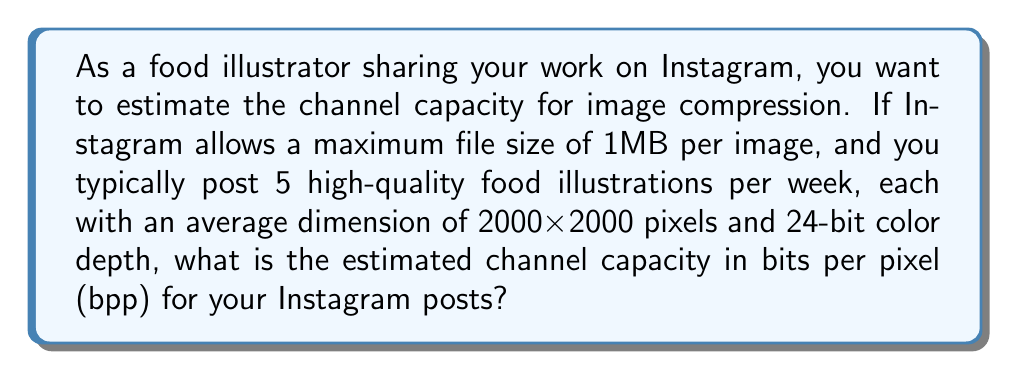Give your solution to this math problem. To solve this problem, we need to follow these steps:

1. Calculate the total number of pixels in each image:
   $$ \text{Total pixels} = 2000 \times 2000 = 4,000,000 \text{ pixels} $$

2. Convert the file size limit from MB to bits:
   $$ 1 \text{MB} = 1,000,000 \text{ bytes} = 8,000,000 \text{ bits} $$

3. Calculate the channel capacity in bits per pixel (bpp):
   $$ \text{Channel capacity} = \frac{\text{File size in bits}}{\text{Total pixels}} $$
   $$ \text{Channel capacity} = \frac{8,000,000 \text{ bits}}{4,000,000 \text{ pixels}} = 2 \text{ bpp} $$

4. Compare this to the original bit depth:
   The original bit depth is 24 bits per pixel (8 bits each for red, green, and blue channels).

5. Calculate the compression ratio:
   $$ \text{Compression ratio} = \frac{\text{Original bit depth}}{\text{Channel capacity}} $$
   $$ \text{Compression ratio} = \frac{24 \text{ bpp}}{2 \text{ bpp}} = 12:1 $$

This means that Instagram's compression algorithm needs to reduce the image data by a factor of 12 to meet the file size limit.

The channel capacity of 2 bpp indicates the maximum amount of information that can be transmitted per pixel while adhering to Instagram's file size constraints. This compression level allows you to maintain a balance between image quality and file size for your food illustrations.
Answer: The estimated channel capacity for image compression on Instagram is 2 bits per pixel (bpp). 